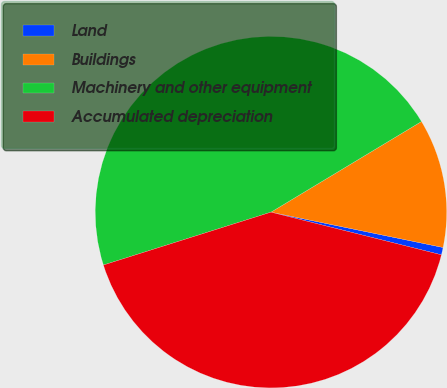Convert chart to OTSL. <chart><loc_0><loc_0><loc_500><loc_500><pie_chart><fcel>Land<fcel>Buildings<fcel>Machinery and other equipment<fcel>Accumulated depreciation<nl><fcel>0.68%<fcel>11.85%<fcel>46.23%<fcel>41.23%<nl></chart> 